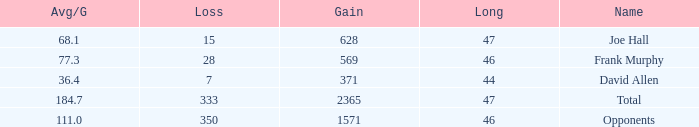How much Avg/G has a Gain smaller than 1571, and a Long smaller than 46? 1.0. 